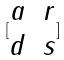Convert formula to latex. <formula><loc_0><loc_0><loc_500><loc_500>[ \begin{matrix} a & r \\ d & s \end{matrix} ]</formula> 